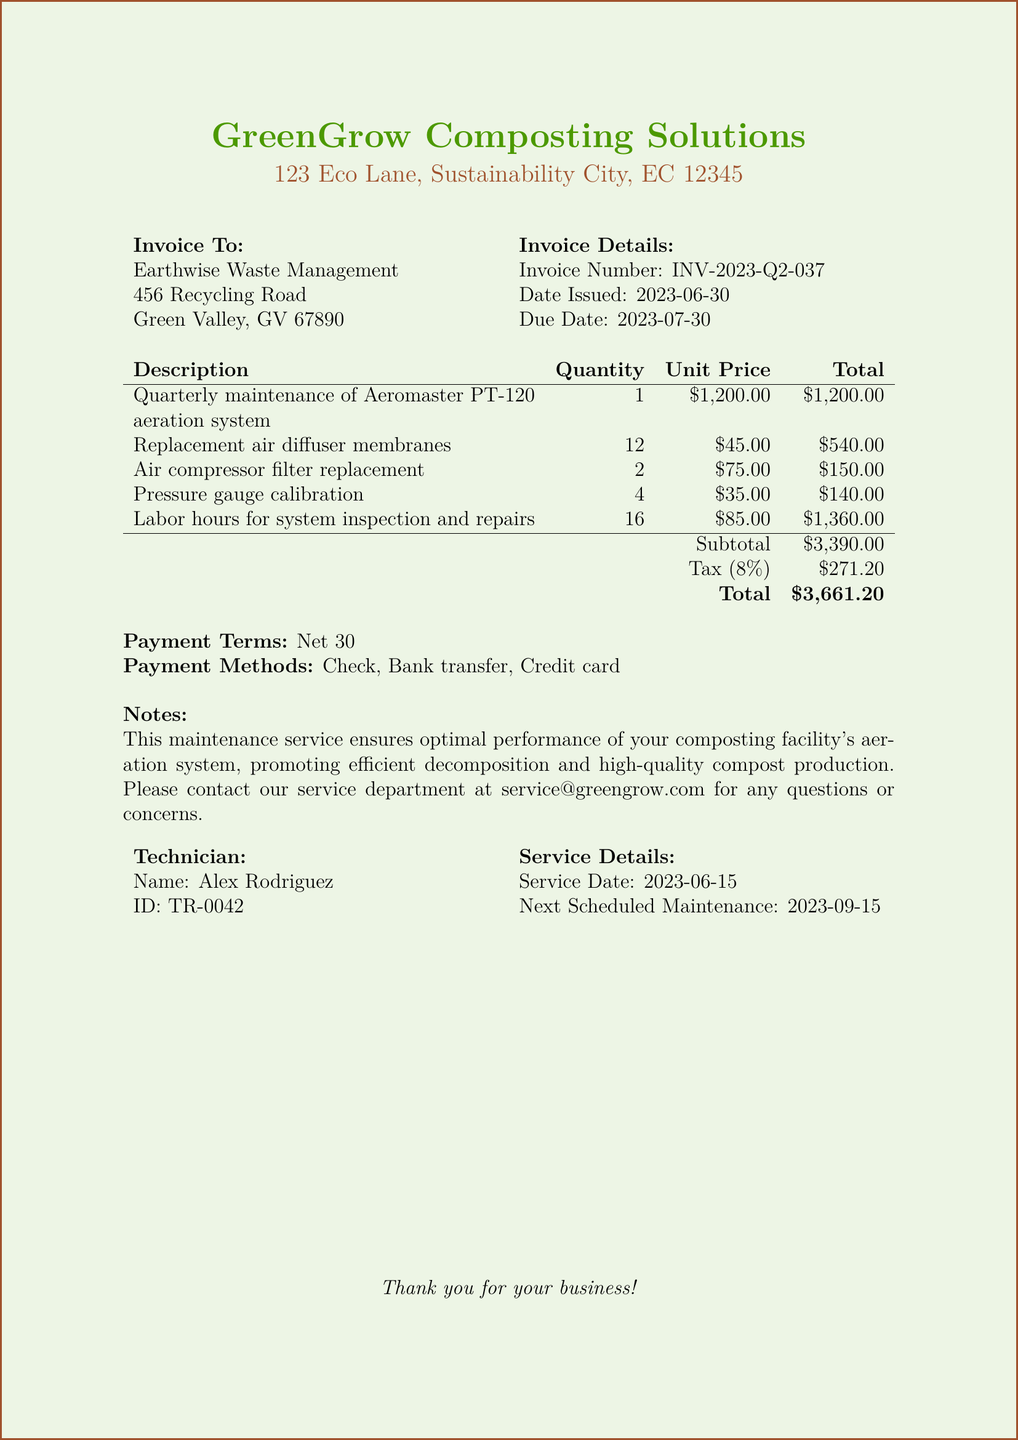what is the invoice number? The invoice number is explicitly stated in the document as a unique identifier for the transaction.
Answer: INV-2023-Q2-037 when was the invoice issued? The date issued is provided in the document, marking when the invoice was created.
Answer: 2023-06-30 what is the total amount due? The total amount is calculated in the invoice, which is the final amount owed by the client.
Answer: $3,661.20 who is the technician responsible for the maintenance? The technician's name is listed under the service details section of the document.
Answer: Alex Rodriguez what is the next scheduled maintenance date? The next scheduled maintenance date is noted in the document, showing when the next service is expected.
Answer: 2023-09-15 how many air diffuser membranes were replaced? The number of replacement air diffuser membranes is recorded in the items list of the invoice.
Answer: 12 what is the tax rate applied to the invoice? The tax rate is specified in the document, indicating the percentage added to the subtotal.
Answer: 8% what are the available payment methods? The document lists the payment methods offered for the invoice transaction.
Answer: Check, Bank transfer, Credit card what does the note mention about the maintenance service? The notes section of the document explains the purpose of the maintenance service and encourages contact for queries.
Answer: Optimal performance of your composting facility's aeration system, promoting efficient decomposition and high-quality compost production 